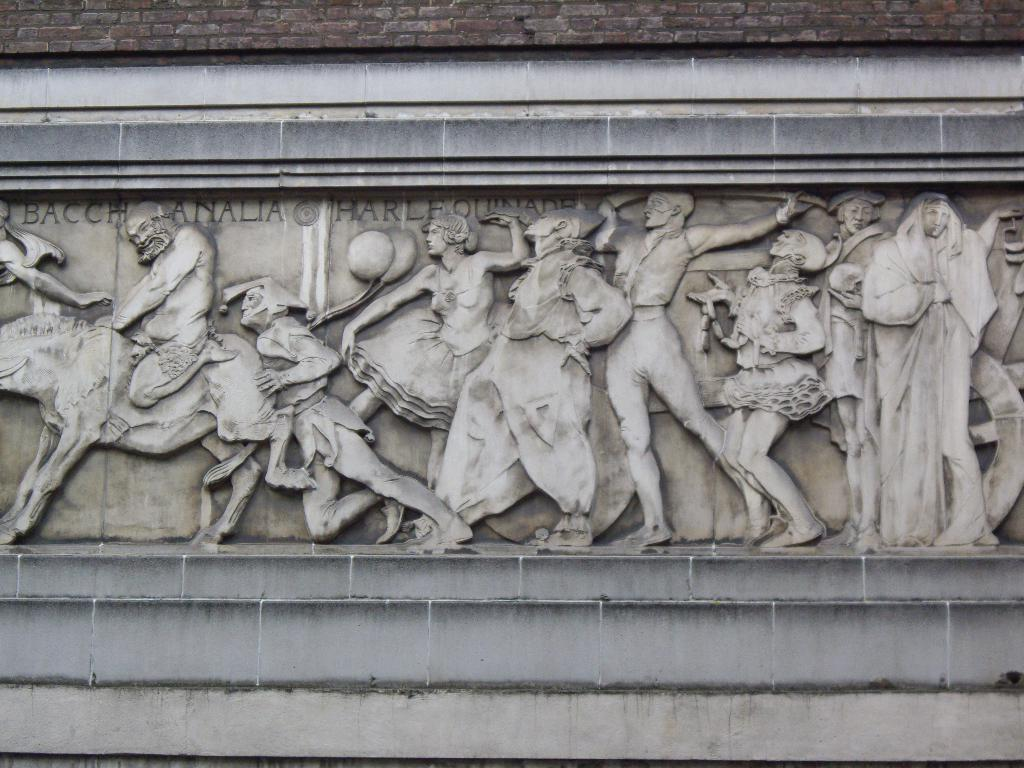What can be seen on the wall in the image? There are words and sculptures on the wall in the image. Can you describe the sculptures on the wall? The sculptures on the wall include people and an animal. What type of belief is being practiced in the church depicted in the image? There is no church depicted in the image; it features words and sculptures on a wall. 